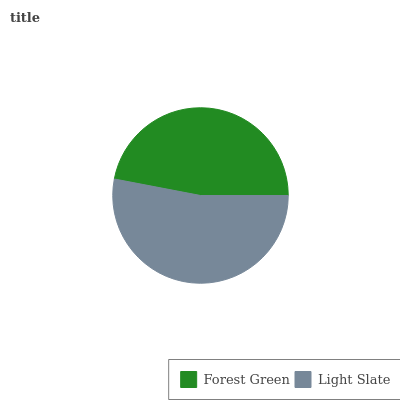Is Forest Green the minimum?
Answer yes or no. Yes. Is Light Slate the maximum?
Answer yes or no. Yes. Is Light Slate the minimum?
Answer yes or no. No. Is Light Slate greater than Forest Green?
Answer yes or no. Yes. Is Forest Green less than Light Slate?
Answer yes or no. Yes. Is Forest Green greater than Light Slate?
Answer yes or no. No. Is Light Slate less than Forest Green?
Answer yes or no. No. Is Light Slate the high median?
Answer yes or no. Yes. Is Forest Green the low median?
Answer yes or no. Yes. Is Forest Green the high median?
Answer yes or no. No. Is Light Slate the low median?
Answer yes or no. No. 